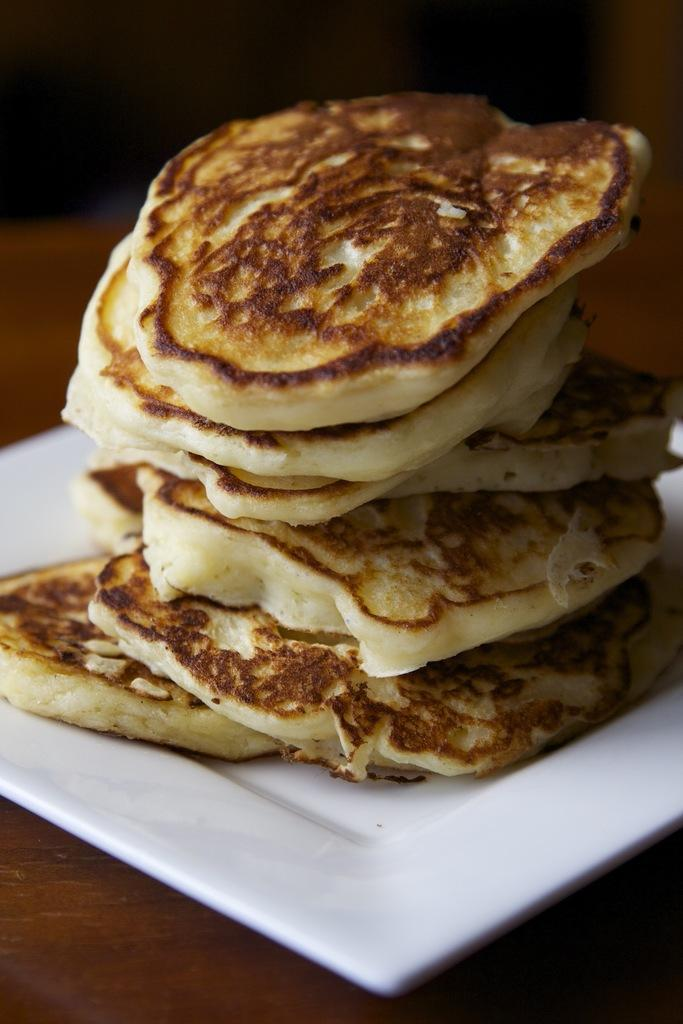What is on the tray in the image? There are food items on a tray in the image. What color is the tray? The tray is white in color. Where is the tray located in the image? The tray is on a surface. What type of map can be seen on the tray in the image? There is no map present on the tray in the image; it contains food items. What kind of fowl is visible on the tray in the image? There is no fowl present on the tray in the image; it contains food items. 